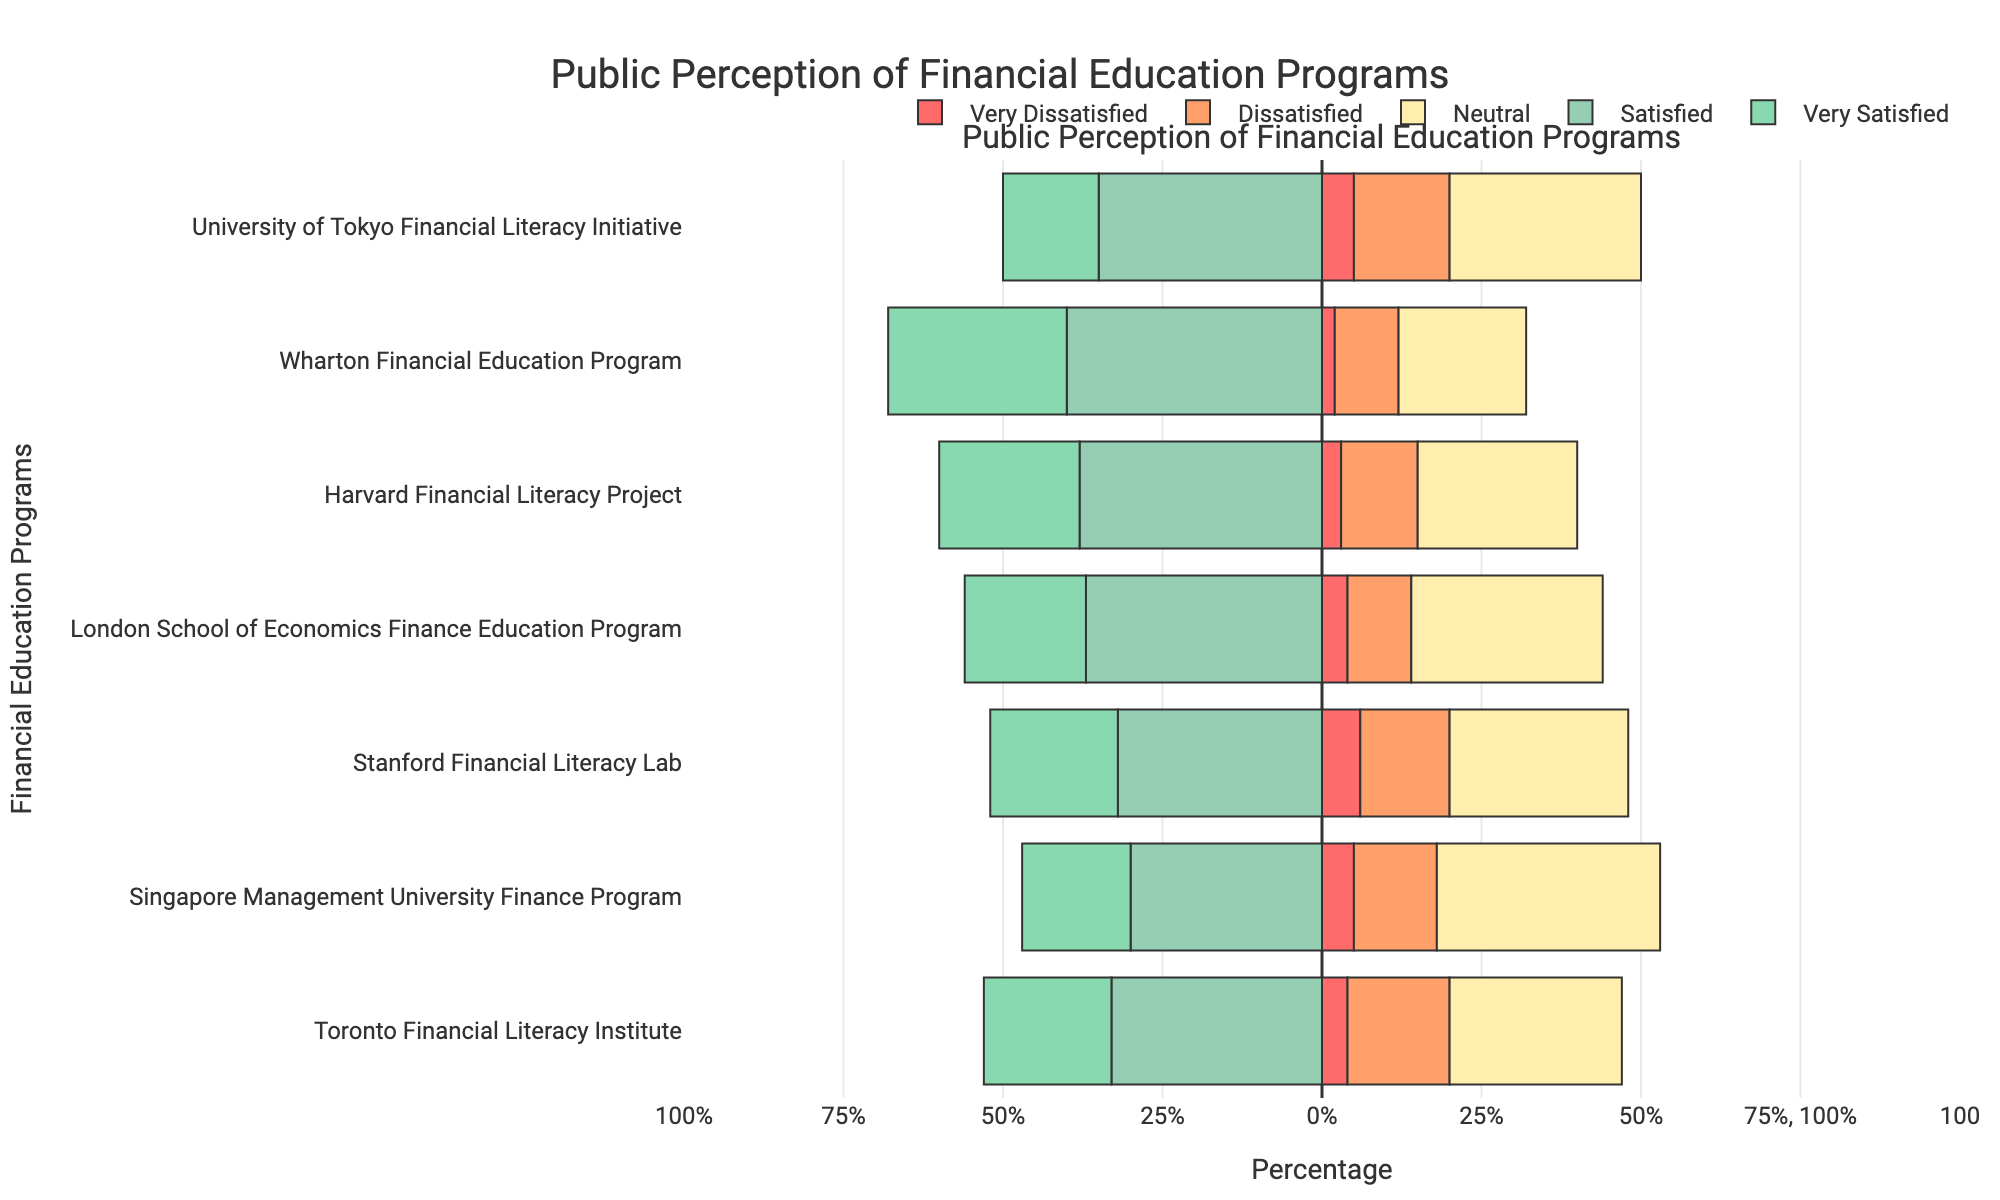Which program has the highest percentage of "Very Satisfied" responses? By examining the lengths of the green bars representing the "Very Satisfied" category, we can see that the "Wharton Financial Education Program" has the longest green bar. This correlates with the highest percentage in this category.
Answer: Wharton Financial Education Program How does the percentage of "Dissatisfied" responses for the "Stanford Financial Literacy Lab" compare to that of the "Tokyo Financial Literacy Initiative"? By looking at the orange bars, we see the length of the "Dissatisfied" bar for "Stanford Financial Literacy Lab" is 14%, while for "Tokyo Financial Literacy Initiative" it is 15%, indicating that the percentage is slightly lower for Stanford.
Answer: Stanford is lower by 1% Which program has the greatest difference between "Satisfied" and "Very Satisfied" percentages? The "Satisfied" and "Very Satisfied" categories are represented by the light blue and green bars, respectively. The "Wharton Financial Education Program" has the highest percentages in both categories, with 40% "Satisfied" and 28% "Very Satisfied", leading to a difference of 40% - 28% = 12%.
Answer: Wharton Financial Education Program What is the combined percentage of "Very Dissatisfied" and "Dissatisfied" responses for "Toronto Financial Literacy Institute"? The "Very Dissatisfied" and "Dissatisfied" categories are represented by the red and orange bars. For "Toronto Financial Literacy Institute", the percentages are 4% and 16% respectively. Summing them gives 4% + 16% = 20%.
Answer: 20% Which program has the lowest percentage of "Neutral" responses, and what is that percentage? By examining the yellow bars representing "Neutral" responses, the shortest bar belongs to the "Wharton Financial Education Program" with a percentage of 20%.
Answer: Wharton Financial Education Program, 20% Considering "London School of Economics Finance Education Program" and "Singapore Management University Finance Program," which has a higher combined percentage for "Satisfied" and "Very Satisfied" responses, and by how much? "London School of Economics Finance Education Program" has 37% "Satisfied" and 19% "Very Satisfied," combining to 56%. "Singapore Management University Finance Program" has 30% "Satisfied" and 17% "Very Satisfied," combining to 47%. The difference is 56% - 47% = 9%.
Answer: London School of Economics Finance Education Program, 9% What is the total percentage of responses that are either "Satisfied" or "Very Satisfied" for "Harvard Financial Literacy Project"? The "Satisfied" and "Very Satisfied" categories are represented by the light blue and green bars. For "Harvard Financial Literacy Project," the percentages are 38% and 22% respectively. Summing them gives 38% + 22% = 60%.
Answer: 60% How many programs have more than 50% of their responses falling into the "Neutral" category? By examining the yellow bars representing the "Neutral" responses, we can see that none of the programs have more than 50% in this category.
Answer: 0 programs Which program shows the highest dissatisfaction (combination of "Very Dissatisfied" and "Dissatisfied")? By summing the red and orange bars for all programs, the "Tokyo Financial Literacy Initiative" has the highest combined percentage of "Very Dissatisfied" and "Dissatisfied" responses at 5% + 15% = 20%.
Answer: Tokyo Financial Literacy Initiative Compared to "Stanford Financial Literacy Lab," which program has a higher percentage of "Very Dissatisfied" responses, and what's the difference? "Stanford Financial Literacy Lab" has 6% "Very Dissatisfied". By inspecting the red bars, no program has a higher percentage of "Very Dissatisfied" responses compared to Stanford.
Answer: None 